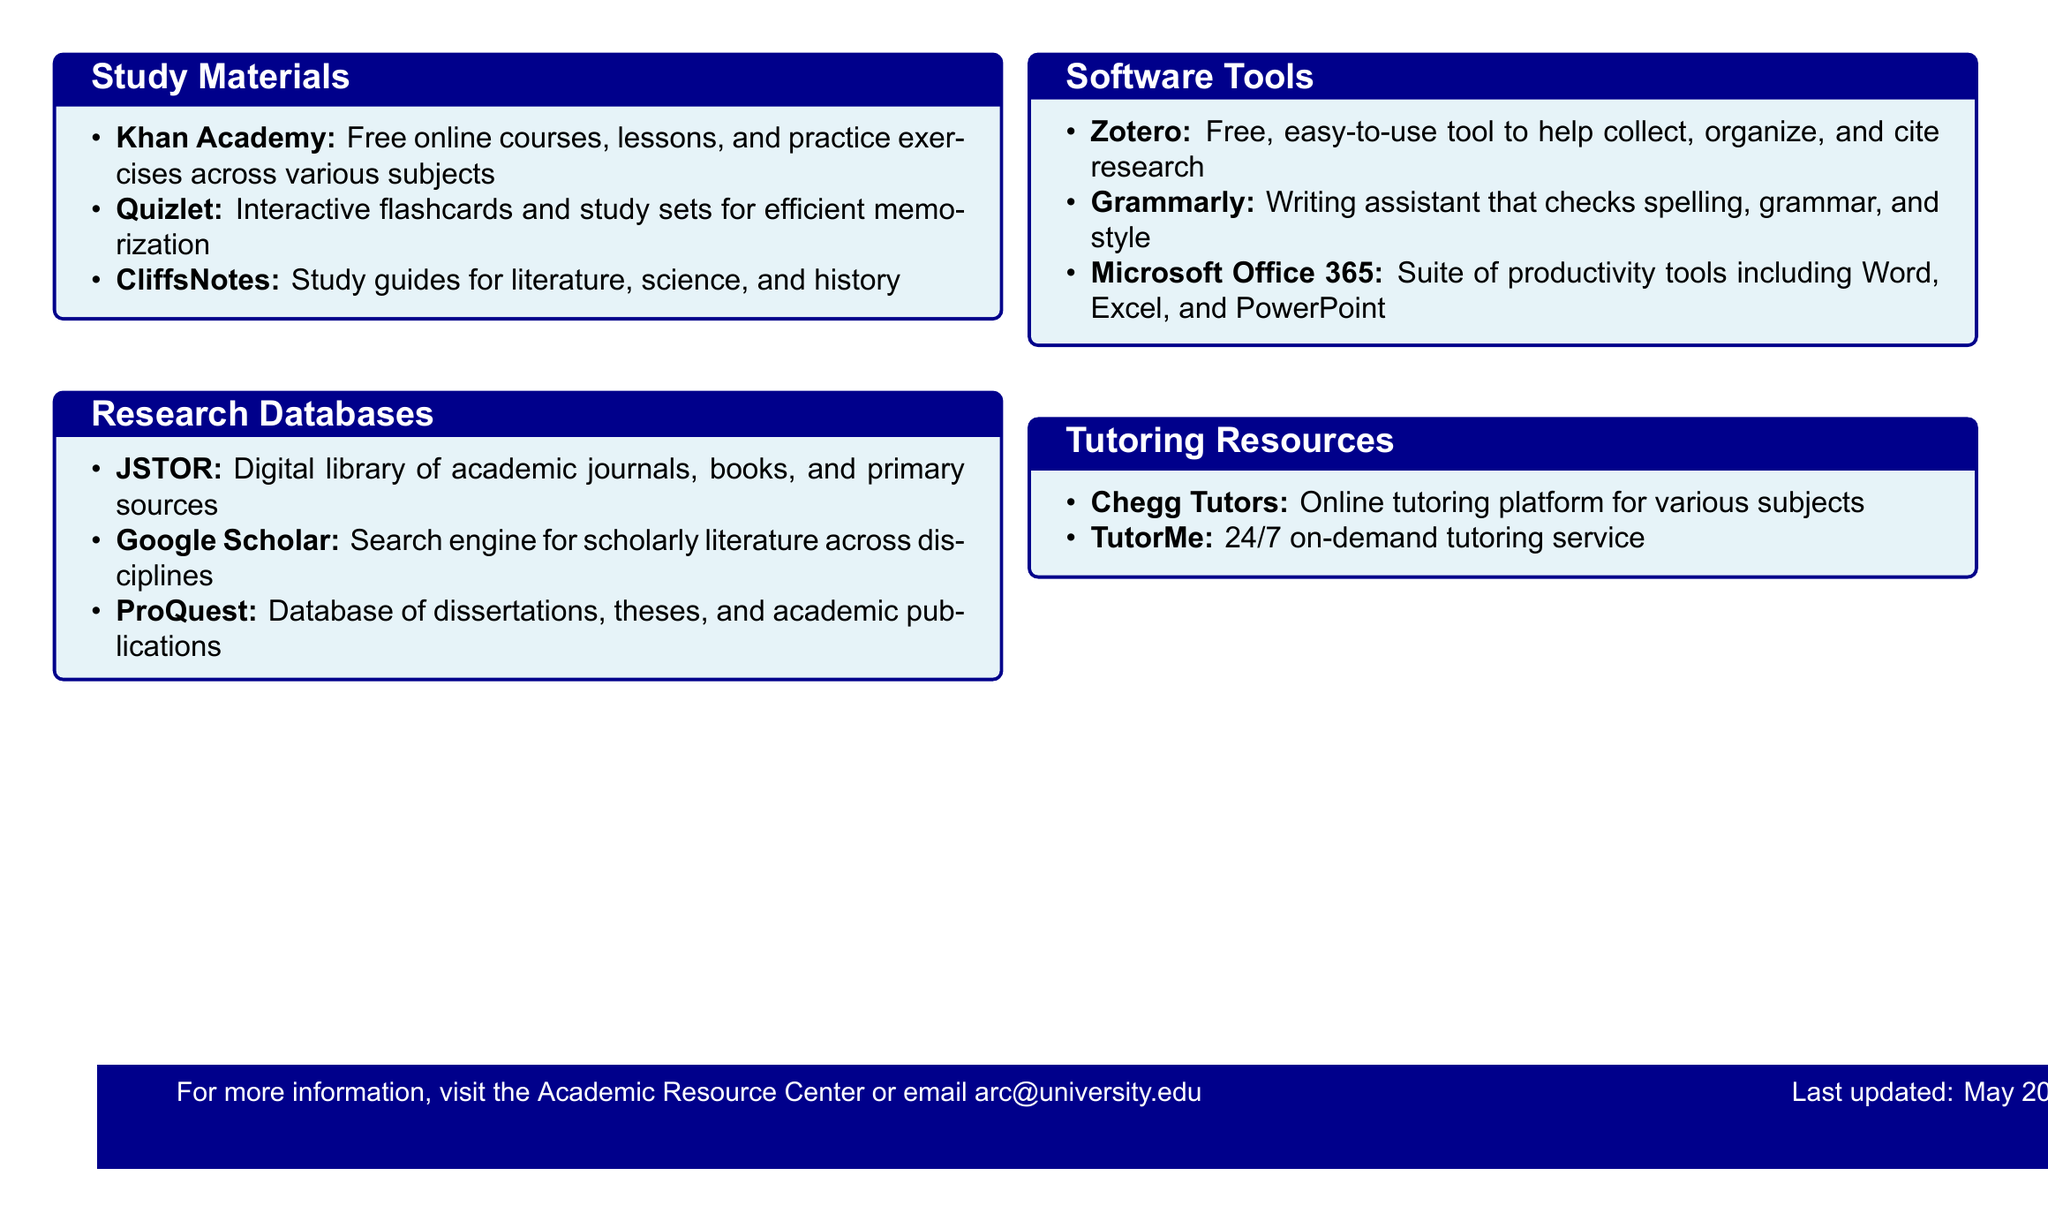What online platform offers free courses across various subjects? The document lists Khan Academy as a free online course platform.
Answer: Khan Academy Which database is described as a digital library of academic journals? The document mentions JSTOR as a digital library for academic journals, books, and primary sources.
Answer: JSTOR What tool helps to collect, organize, and cite research? Zotero is identified in the document as a tool for collecting, organizing, and citing research.
Answer: Zotero How many tutoring resources are mentioned in the document? The document lists two tutoring resources: Chegg Tutors and TutorMe.
Answer: 2 What is the title of the catalog? The title provided in the document reveals the purpose of the resource catalog for honor roll students.
Answer: Academic Success Resources for Honor Roll Students Which writing assistant checks spelling, grammar, and style? The document describes Grammarly as the writing assistant that performs these functions.
Answer: Grammarly What is the email address listed for more information? The document provides an email address for the Academic Resource Center, which is used for inquiries.
Answer: arc@university.edu Which software suite includes Word, Excel, and PowerPoint? Microsoft Office 365 is specified in the document as the software suite containing these productivity tools.
Answer: Microsoft Office 365 